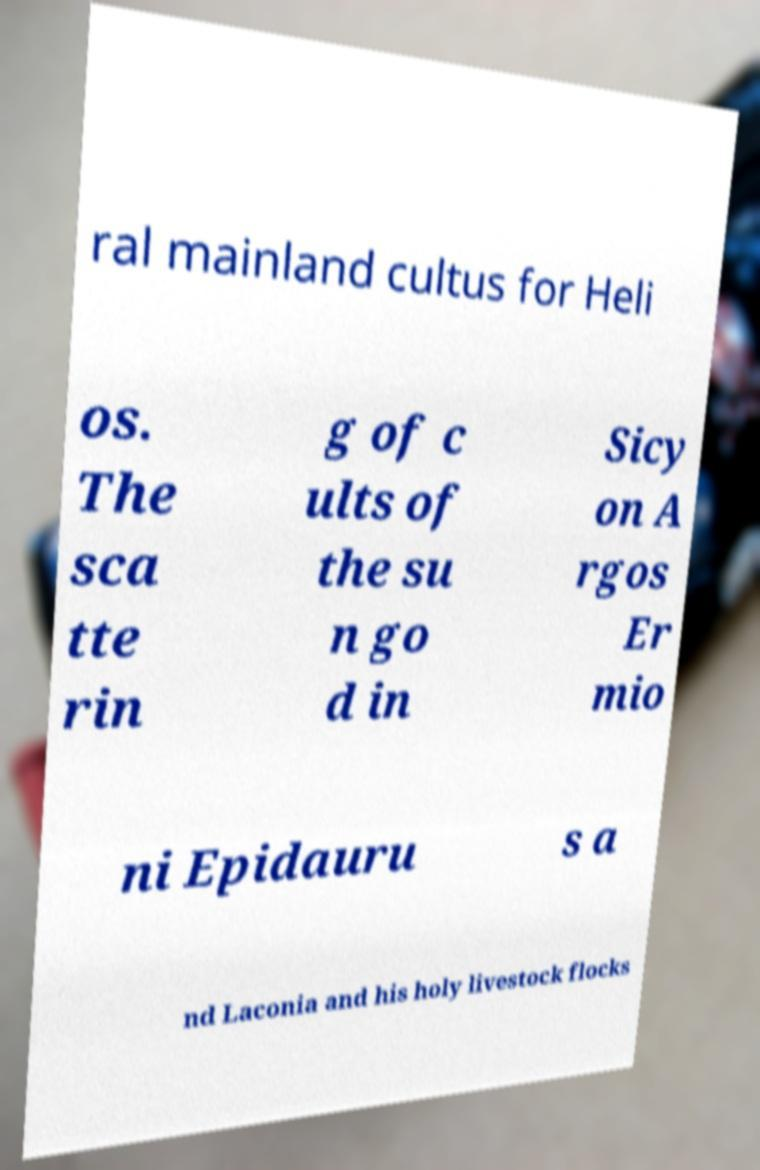There's text embedded in this image that I need extracted. Can you transcribe it verbatim? ral mainland cultus for Heli os. The sca tte rin g of c ults of the su n go d in Sicy on A rgos Er mio ni Epidauru s a nd Laconia and his holy livestock flocks 